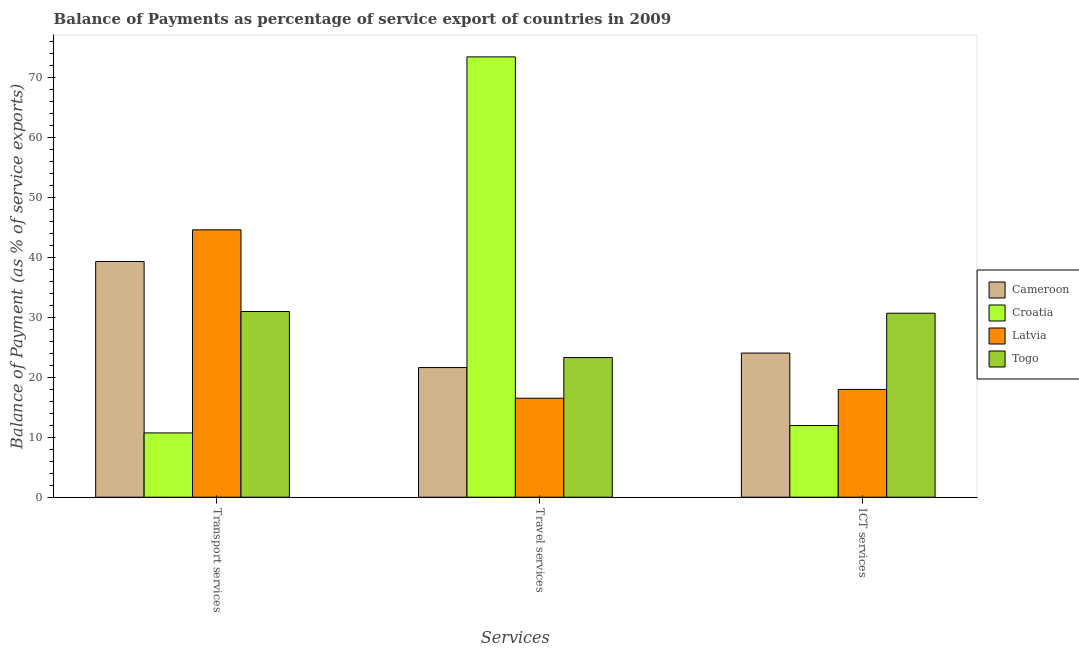How many different coloured bars are there?
Ensure brevity in your answer.  4. How many groups of bars are there?
Your answer should be compact. 3. Are the number of bars per tick equal to the number of legend labels?
Provide a short and direct response. Yes. How many bars are there on the 3rd tick from the left?
Your answer should be very brief. 4. What is the label of the 2nd group of bars from the left?
Give a very brief answer. Travel services. What is the balance of payment of travel services in Togo?
Your answer should be compact. 23.27. Across all countries, what is the maximum balance of payment of transport services?
Keep it short and to the point. 44.55. Across all countries, what is the minimum balance of payment of ict services?
Make the answer very short. 11.94. In which country was the balance of payment of ict services maximum?
Provide a short and direct response. Togo. In which country was the balance of payment of travel services minimum?
Keep it short and to the point. Latvia. What is the total balance of payment of travel services in the graph?
Your answer should be compact. 134.75. What is the difference between the balance of payment of transport services in Togo and that in Croatia?
Make the answer very short. 20.23. What is the difference between the balance of payment of travel services in Croatia and the balance of payment of ict services in Togo?
Offer a terse response. 42.71. What is the average balance of payment of transport services per country?
Give a very brief answer. 31.37. What is the difference between the balance of payment of transport services and balance of payment of ict services in Latvia?
Your answer should be compact. 26.59. What is the ratio of the balance of payment of travel services in Togo to that in Latvia?
Offer a very short reply. 1.41. Is the difference between the balance of payment of travel services in Cameroon and Togo greater than the difference between the balance of payment of transport services in Cameroon and Togo?
Ensure brevity in your answer.  No. What is the difference between the highest and the second highest balance of payment of transport services?
Your answer should be compact. 5.27. What is the difference between the highest and the lowest balance of payment of ict services?
Give a very brief answer. 18.72. What does the 3rd bar from the left in ICT services represents?
Offer a very short reply. Latvia. What does the 4th bar from the right in ICT services represents?
Offer a very short reply. Cameroon. How many countries are there in the graph?
Ensure brevity in your answer.  4. Does the graph contain any zero values?
Provide a short and direct response. No. What is the title of the graph?
Give a very brief answer. Balance of Payments as percentage of service export of countries in 2009. Does "Dominica" appear as one of the legend labels in the graph?
Provide a succinct answer. No. What is the label or title of the X-axis?
Your answer should be compact. Services. What is the label or title of the Y-axis?
Your answer should be compact. Balance of Payment (as % of service exports). What is the Balance of Payment (as % of service exports) of Cameroon in Transport services?
Your answer should be compact. 39.28. What is the Balance of Payment (as % of service exports) of Croatia in Transport services?
Ensure brevity in your answer.  10.71. What is the Balance of Payment (as % of service exports) in Latvia in Transport services?
Your response must be concise. 44.55. What is the Balance of Payment (as % of service exports) in Togo in Transport services?
Your answer should be compact. 30.94. What is the Balance of Payment (as % of service exports) of Cameroon in Travel services?
Give a very brief answer. 21.6. What is the Balance of Payment (as % of service exports) in Croatia in Travel services?
Keep it short and to the point. 73.37. What is the Balance of Payment (as % of service exports) of Latvia in Travel services?
Ensure brevity in your answer.  16.5. What is the Balance of Payment (as % of service exports) in Togo in Travel services?
Your response must be concise. 23.27. What is the Balance of Payment (as % of service exports) of Cameroon in ICT services?
Ensure brevity in your answer.  24.02. What is the Balance of Payment (as % of service exports) of Croatia in ICT services?
Give a very brief answer. 11.94. What is the Balance of Payment (as % of service exports) in Latvia in ICT services?
Your answer should be very brief. 17.96. What is the Balance of Payment (as % of service exports) in Togo in ICT services?
Your answer should be very brief. 30.66. Across all Services, what is the maximum Balance of Payment (as % of service exports) in Cameroon?
Your response must be concise. 39.28. Across all Services, what is the maximum Balance of Payment (as % of service exports) in Croatia?
Offer a terse response. 73.37. Across all Services, what is the maximum Balance of Payment (as % of service exports) in Latvia?
Provide a succinct answer. 44.55. Across all Services, what is the maximum Balance of Payment (as % of service exports) of Togo?
Your response must be concise. 30.94. Across all Services, what is the minimum Balance of Payment (as % of service exports) of Cameroon?
Your response must be concise. 21.6. Across all Services, what is the minimum Balance of Payment (as % of service exports) of Croatia?
Offer a very short reply. 10.71. Across all Services, what is the minimum Balance of Payment (as % of service exports) in Latvia?
Offer a terse response. 16.5. Across all Services, what is the minimum Balance of Payment (as % of service exports) of Togo?
Your response must be concise. 23.27. What is the total Balance of Payment (as % of service exports) in Cameroon in the graph?
Offer a very short reply. 84.9. What is the total Balance of Payment (as % of service exports) in Croatia in the graph?
Provide a succinct answer. 96.03. What is the total Balance of Payment (as % of service exports) in Latvia in the graph?
Your answer should be very brief. 79.01. What is the total Balance of Payment (as % of service exports) in Togo in the graph?
Provide a short and direct response. 84.88. What is the difference between the Balance of Payment (as % of service exports) of Cameroon in Transport services and that in Travel services?
Ensure brevity in your answer.  17.68. What is the difference between the Balance of Payment (as % of service exports) in Croatia in Transport services and that in Travel services?
Provide a succinct answer. -62.66. What is the difference between the Balance of Payment (as % of service exports) of Latvia in Transport services and that in Travel services?
Make the answer very short. 28.05. What is the difference between the Balance of Payment (as % of service exports) of Togo in Transport services and that in Travel services?
Ensure brevity in your answer.  7.67. What is the difference between the Balance of Payment (as % of service exports) of Cameroon in Transport services and that in ICT services?
Offer a very short reply. 15.26. What is the difference between the Balance of Payment (as % of service exports) in Croatia in Transport services and that in ICT services?
Your response must be concise. -1.23. What is the difference between the Balance of Payment (as % of service exports) of Latvia in Transport services and that in ICT services?
Offer a terse response. 26.59. What is the difference between the Balance of Payment (as % of service exports) in Togo in Transport services and that in ICT services?
Offer a very short reply. 0.28. What is the difference between the Balance of Payment (as % of service exports) of Cameroon in Travel services and that in ICT services?
Give a very brief answer. -2.41. What is the difference between the Balance of Payment (as % of service exports) in Croatia in Travel services and that in ICT services?
Offer a terse response. 61.43. What is the difference between the Balance of Payment (as % of service exports) in Latvia in Travel services and that in ICT services?
Your answer should be compact. -1.46. What is the difference between the Balance of Payment (as % of service exports) in Togo in Travel services and that in ICT services?
Offer a very short reply. -7.39. What is the difference between the Balance of Payment (as % of service exports) of Cameroon in Transport services and the Balance of Payment (as % of service exports) of Croatia in Travel services?
Your answer should be very brief. -34.09. What is the difference between the Balance of Payment (as % of service exports) in Cameroon in Transport services and the Balance of Payment (as % of service exports) in Latvia in Travel services?
Provide a succinct answer. 22.78. What is the difference between the Balance of Payment (as % of service exports) in Cameroon in Transport services and the Balance of Payment (as % of service exports) in Togo in Travel services?
Provide a short and direct response. 16.01. What is the difference between the Balance of Payment (as % of service exports) in Croatia in Transport services and the Balance of Payment (as % of service exports) in Latvia in Travel services?
Your answer should be very brief. -5.78. What is the difference between the Balance of Payment (as % of service exports) in Croatia in Transport services and the Balance of Payment (as % of service exports) in Togo in Travel services?
Keep it short and to the point. -12.56. What is the difference between the Balance of Payment (as % of service exports) in Latvia in Transport services and the Balance of Payment (as % of service exports) in Togo in Travel services?
Your answer should be very brief. 21.28. What is the difference between the Balance of Payment (as % of service exports) in Cameroon in Transport services and the Balance of Payment (as % of service exports) in Croatia in ICT services?
Give a very brief answer. 27.34. What is the difference between the Balance of Payment (as % of service exports) in Cameroon in Transport services and the Balance of Payment (as % of service exports) in Latvia in ICT services?
Your response must be concise. 21.32. What is the difference between the Balance of Payment (as % of service exports) of Cameroon in Transport services and the Balance of Payment (as % of service exports) of Togo in ICT services?
Your response must be concise. 8.62. What is the difference between the Balance of Payment (as % of service exports) of Croatia in Transport services and the Balance of Payment (as % of service exports) of Latvia in ICT services?
Offer a very short reply. -7.25. What is the difference between the Balance of Payment (as % of service exports) in Croatia in Transport services and the Balance of Payment (as % of service exports) in Togo in ICT services?
Offer a very short reply. -19.95. What is the difference between the Balance of Payment (as % of service exports) in Latvia in Transport services and the Balance of Payment (as % of service exports) in Togo in ICT services?
Keep it short and to the point. 13.89. What is the difference between the Balance of Payment (as % of service exports) of Cameroon in Travel services and the Balance of Payment (as % of service exports) of Croatia in ICT services?
Your response must be concise. 9.66. What is the difference between the Balance of Payment (as % of service exports) of Cameroon in Travel services and the Balance of Payment (as % of service exports) of Latvia in ICT services?
Offer a terse response. 3.64. What is the difference between the Balance of Payment (as % of service exports) in Cameroon in Travel services and the Balance of Payment (as % of service exports) in Togo in ICT services?
Make the answer very short. -9.06. What is the difference between the Balance of Payment (as % of service exports) of Croatia in Travel services and the Balance of Payment (as % of service exports) of Latvia in ICT services?
Your answer should be compact. 55.41. What is the difference between the Balance of Payment (as % of service exports) in Croatia in Travel services and the Balance of Payment (as % of service exports) in Togo in ICT services?
Your answer should be compact. 42.71. What is the difference between the Balance of Payment (as % of service exports) of Latvia in Travel services and the Balance of Payment (as % of service exports) of Togo in ICT services?
Provide a succinct answer. -14.16. What is the average Balance of Payment (as % of service exports) in Cameroon per Services?
Offer a very short reply. 28.3. What is the average Balance of Payment (as % of service exports) of Croatia per Services?
Ensure brevity in your answer.  32.01. What is the average Balance of Payment (as % of service exports) in Latvia per Services?
Your answer should be compact. 26.34. What is the average Balance of Payment (as % of service exports) of Togo per Services?
Give a very brief answer. 28.29. What is the difference between the Balance of Payment (as % of service exports) of Cameroon and Balance of Payment (as % of service exports) of Croatia in Transport services?
Your answer should be very brief. 28.57. What is the difference between the Balance of Payment (as % of service exports) in Cameroon and Balance of Payment (as % of service exports) in Latvia in Transport services?
Your answer should be compact. -5.27. What is the difference between the Balance of Payment (as % of service exports) of Cameroon and Balance of Payment (as % of service exports) of Togo in Transport services?
Ensure brevity in your answer.  8.34. What is the difference between the Balance of Payment (as % of service exports) of Croatia and Balance of Payment (as % of service exports) of Latvia in Transport services?
Offer a very short reply. -33.84. What is the difference between the Balance of Payment (as % of service exports) in Croatia and Balance of Payment (as % of service exports) in Togo in Transport services?
Ensure brevity in your answer.  -20.23. What is the difference between the Balance of Payment (as % of service exports) of Latvia and Balance of Payment (as % of service exports) of Togo in Transport services?
Give a very brief answer. 13.61. What is the difference between the Balance of Payment (as % of service exports) of Cameroon and Balance of Payment (as % of service exports) of Croatia in Travel services?
Ensure brevity in your answer.  -51.77. What is the difference between the Balance of Payment (as % of service exports) of Cameroon and Balance of Payment (as % of service exports) of Latvia in Travel services?
Your answer should be very brief. 5.11. What is the difference between the Balance of Payment (as % of service exports) in Cameroon and Balance of Payment (as % of service exports) in Togo in Travel services?
Your answer should be compact. -1.67. What is the difference between the Balance of Payment (as % of service exports) in Croatia and Balance of Payment (as % of service exports) in Latvia in Travel services?
Give a very brief answer. 56.88. What is the difference between the Balance of Payment (as % of service exports) of Croatia and Balance of Payment (as % of service exports) of Togo in Travel services?
Make the answer very short. 50.1. What is the difference between the Balance of Payment (as % of service exports) in Latvia and Balance of Payment (as % of service exports) in Togo in Travel services?
Offer a terse response. -6.78. What is the difference between the Balance of Payment (as % of service exports) in Cameroon and Balance of Payment (as % of service exports) in Croatia in ICT services?
Keep it short and to the point. 12.07. What is the difference between the Balance of Payment (as % of service exports) in Cameroon and Balance of Payment (as % of service exports) in Latvia in ICT services?
Your answer should be compact. 6.06. What is the difference between the Balance of Payment (as % of service exports) in Cameroon and Balance of Payment (as % of service exports) in Togo in ICT services?
Offer a terse response. -6.64. What is the difference between the Balance of Payment (as % of service exports) of Croatia and Balance of Payment (as % of service exports) of Latvia in ICT services?
Keep it short and to the point. -6.02. What is the difference between the Balance of Payment (as % of service exports) of Croatia and Balance of Payment (as % of service exports) of Togo in ICT services?
Provide a succinct answer. -18.72. What is the difference between the Balance of Payment (as % of service exports) of Latvia and Balance of Payment (as % of service exports) of Togo in ICT services?
Your answer should be very brief. -12.7. What is the ratio of the Balance of Payment (as % of service exports) in Cameroon in Transport services to that in Travel services?
Offer a terse response. 1.82. What is the ratio of the Balance of Payment (as % of service exports) of Croatia in Transport services to that in Travel services?
Provide a short and direct response. 0.15. What is the ratio of the Balance of Payment (as % of service exports) in Latvia in Transport services to that in Travel services?
Your response must be concise. 2.7. What is the ratio of the Balance of Payment (as % of service exports) of Togo in Transport services to that in Travel services?
Your answer should be very brief. 1.33. What is the ratio of the Balance of Payment (as % of service exports) in Cameroon in Transport services to that in ICT services?
Offer a very short reply. 1.64. What is the ratio of the Balance of Payment (as % of service exports) of Croatia in Transport services to that in ICT services?
Keep it short and to the point. 0.9. What is the ratio of the Balance of Payment (as % of service exports) in Latvia in Transport services to that in ICT services?
Your answer should be compact. 2.48. What is the ratio of the Balance of Payment (as % of service exports) in Togo in Transport services to that in ICT services?
Keep it short and to the point. 1.01. What is the ratio of the Balance of Payment (as % of service exports) in Cameroon in Travel services to that in ICT services?
Your response must be concise. 0.9. What is the ratio of the Balance of Payment (as % of service exports) in Croatia in Travel services to that in ICT services?
Your answer should be very brief. 6.14. What is the ratio of the Balance of Payment (as % of service exports) of Latvia in Travel services to that in ICT services?
Offer a terse response. 0.92. What is the ratio of the Balance of Payment (as % of service exports) of Togo in Travel services to that in ICT services?
Provide a short and direct response. 0.76. What is the difference between the highest and the second highest Balance of Payment (as % of service exports) in Cameroon?
Provide a short and direct response. 15.26. What is the difference between the highest and the second highest Balance of Payment (as % of service exports) in Croatia?
Ensure brevity in your answer.  61.43. What is the difference between the highest and the second highest Balance of Payment (as % of service exports) in Latvia?
Ensure brevity in your answer.  26.59. What is the difference between the highest and the second highest Balance of Payment (as % of service exports) in Togo?
Offer a very short reply. 0.28. What is the difference between the highest and the lowest Balance of Payment (as % of service exports) in Cameroon?
Your response must be concise. 17.68. What is the difference between the highest and the lowest Balance of Payment (as % of service exports) of Croatia?
Your answer should be very brief. 62.66. What is the difference between the highest and the lowest Balance of Payment (as % of service exports) in Latvia?
Your response must be concise. 28.05. What is the difference between the highest and the lowest Balance of Payment (as % of service exports) in Togo?
Keep it short and to the point. 7.67. 